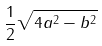Convert formula to latex. <formula><loc_0><loc_0><loc_500><loc_500>\frac { 1 } { 2 } \sqrt { 4 a ^ { 2 } - b ^ { 2 } }</formula> 